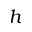<formula> <loc_0><loc_0><loc_500><loc_500>h</formula> 